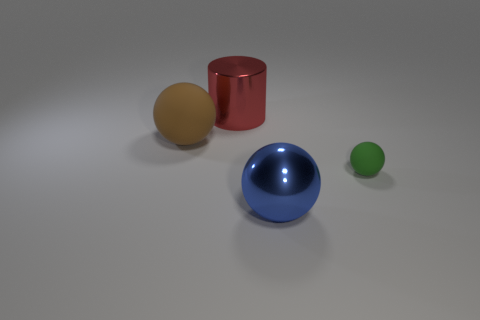Subtract all brown matte balls. How many balls are left? 2 Add 1 blue metal things. How many objects exist? 5 Subtract all spheres. How many objects are left? 1 Add 1 tiny blue shiny cylinders. How many tiny blue shiny cylinders exist? 1 Subtract 0 yellow cylinders. How many objects are left? 4 Subtract all yellow cylinders. Subtract all brown blocks. How many cylinders are left? 1 Subtract all purple spheres. How many green cylinders are left? 0 Subtract all small cyan rubber blocks. Subtract all brown matte objects. How many objects are left? 3 Add 3 matte spheres. How many matte spheres are left? 5 